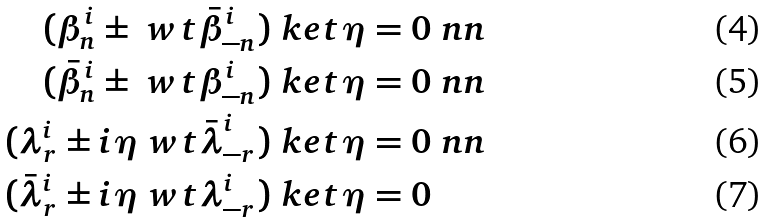Convert formula to latex. <formula><loc_0><loc_0><loc_500><loc_500>( \beta ^ { i } _ { n } \pm \ w t { \bar { \beta } } ^ { i } _ { - n } ) \ k e t { \eta } & = 0 \ n n \\ ( \bar { \beta } ^ { i } _ { n } \pm \ w t { \beta } ^ { i } _ { - n } ) \ k e t { \eta } & = 0 \ n n \\ ( \lambda ^ { i } _ { r } \pm i \eta { \ w t { \bar { \lambda } } } ^ { i } _ { - r } ) \ k e t { \eta } & = 0 \ n n \\ ( \bar { \lambda } ^ { i } _ { r } \pm i \eta \ w t { \lambda } ^ { i } _ { - r } ) \ k e t { \eta } & = 0</formula> 